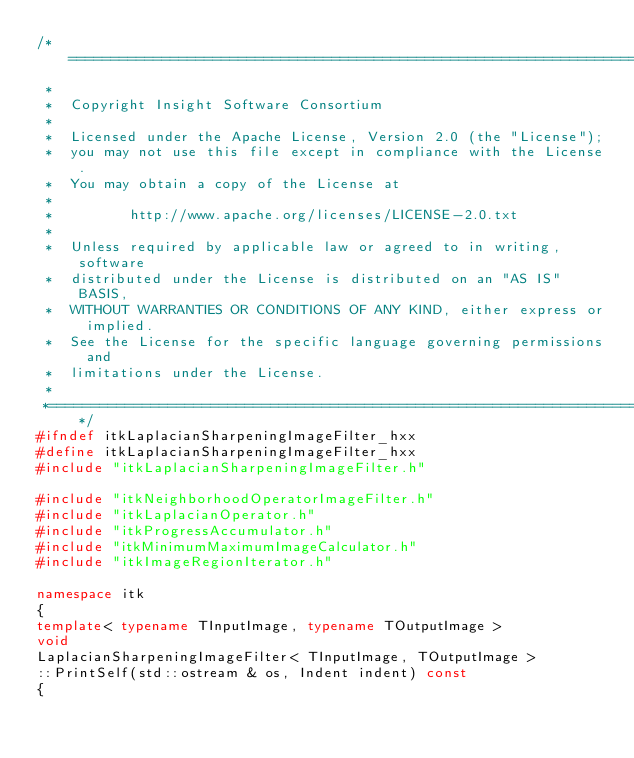<code> <loc_0><loc_0><loc_500><loc_500><_C++_>/*=========================================================================
 *
 *  Copyright Insight Software Consortium
 *
 *  Licensed under the Apache License, Version 2.0 (the "License");
 *  you may not use this file except in compliance with the License.
 *  You may obtain a copy of the License at
 *
 *         http://www.apache.org/licenses/LICENSE-2.0.txt
 *
 *  Unless required by applicable law or agreed to in writing, software
 *  distributed under the License is distributed on an "AS IS" BASIS,
 *  WITHOUT WARRANTIES OR CONDITIONS OF ANY KIND, either express or implied.
 *  See the License for the specific language governing permissions and
 *  limitations under the License.
 *
 *=========================================================================*/
#ifndef itkLaplacianSharpeningImageFilter_hxx
#define itkLaplacianSharpeningImageFilter_hxx
#include "itkLaplacianSharpeningImageFilter.h"

#include "itkNeighborhoodOperatorImageFilter.h"
#include "itkLaplacianOperator.h"
#include "itkProgressAccumulator.h"
#include "itkMinimumMaximumImageCalculator.h"
#include "itkImageRegionIterator.h"

namespace itk
{
template< typename TInputImage, typename TOutputImage >
void
LaplacianSharpeningImageFilter< TInputImage, TOutputImage >
::PrintSelf(std::ostream & os, Indent indent) const
{</code> 